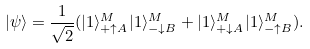<formula> <loc_0><loc_0><loc_500><loc_500>| \psi \rangle = \frac { 1 } { \sqrt { 2 } } ( | 1 \rangle ^ { M } _ { + \uparrow A } | 1 \rangle ^ { M } _ { - \downarrow B } + | 1 \rangle ^ { M } _ { + \downarrow A } | 1 \rangle ^ { M } _ { - \uparrow B } ) .</formula> 